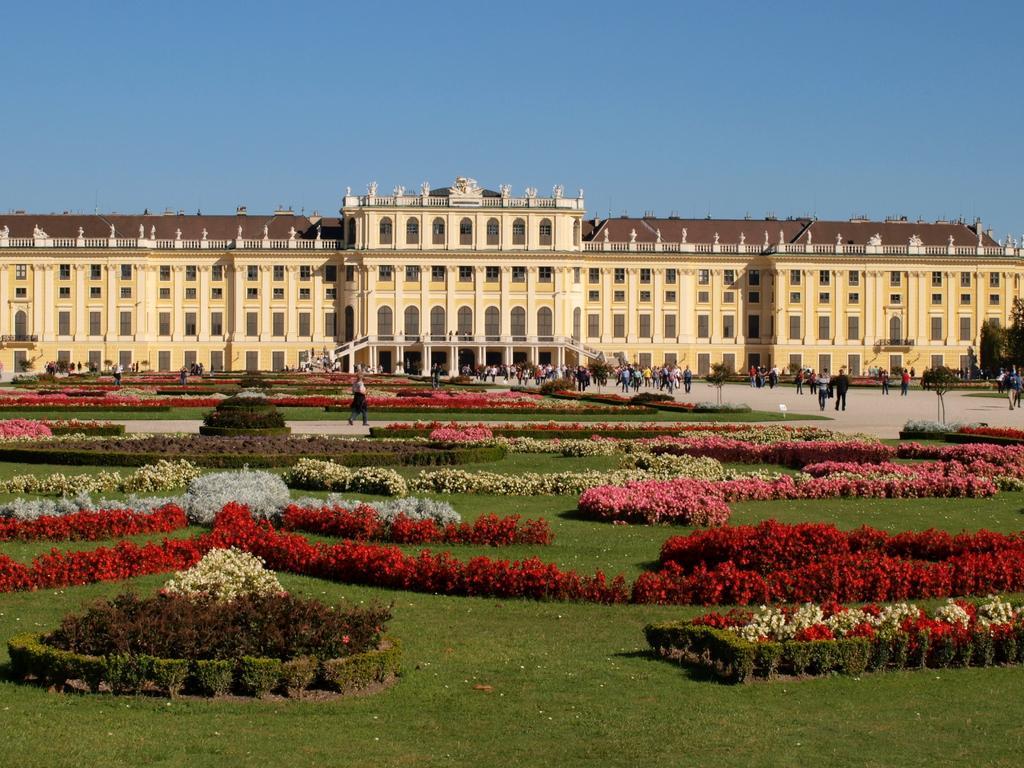How would you summarize this image in a sentence or two? In this picture I can see a building and group of people standing on the ground. Here I can see a garden which has plants and grass. In the background I can see the sky. 